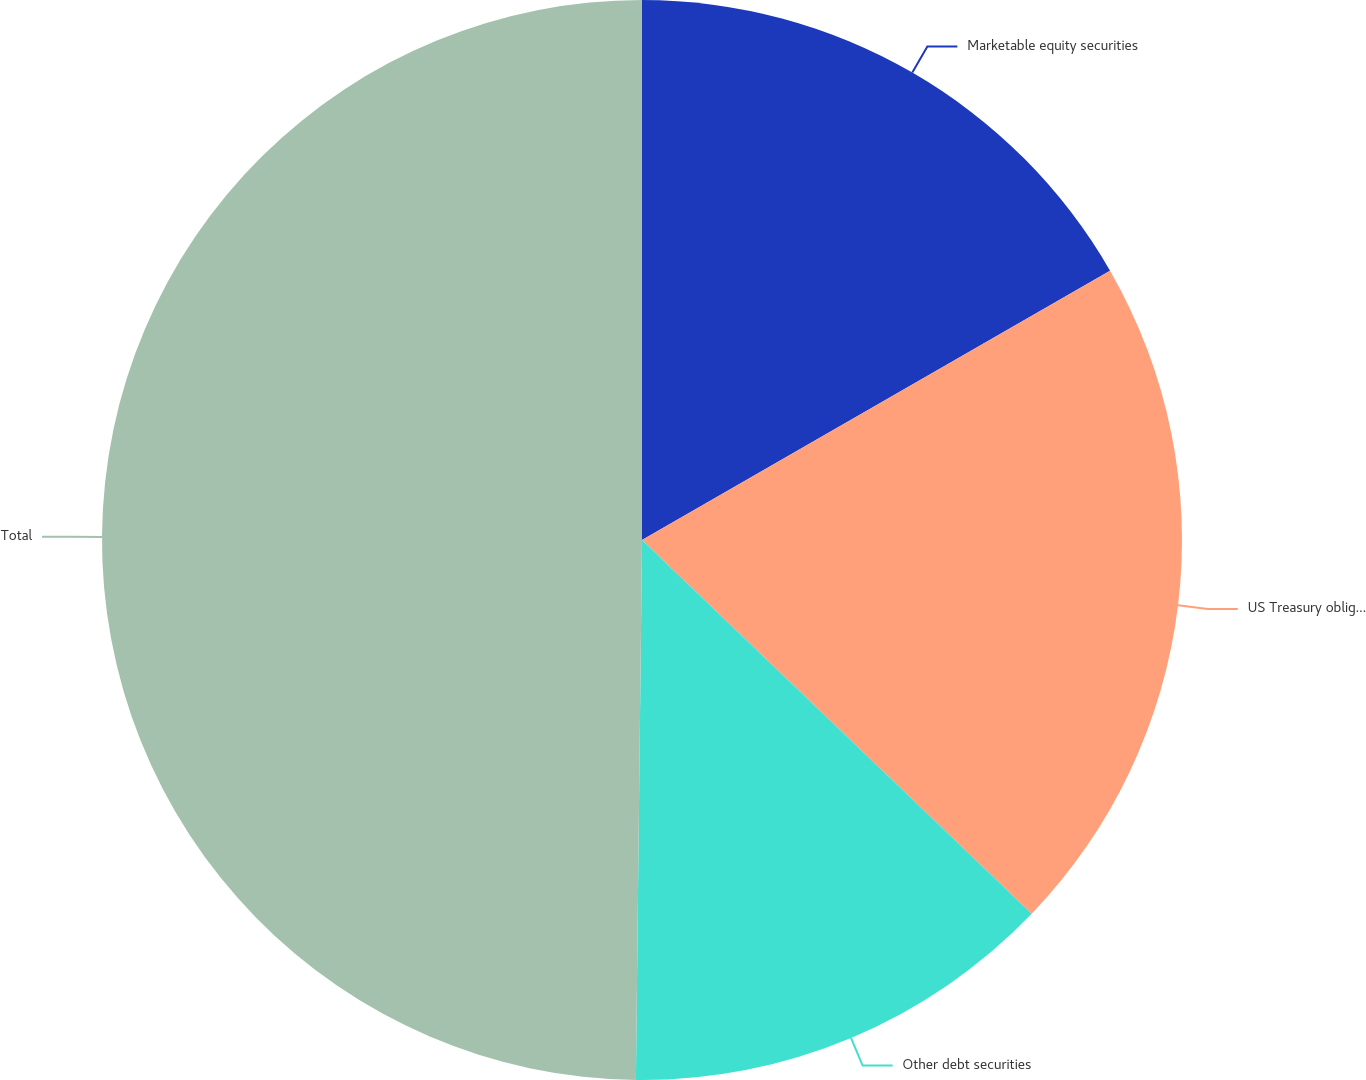Convert chart to OTSL. <chart><loc_0><loc_0><loc_500><loc_500><pie_chart><fcel>Marketable equity securities<fcel>US Treasury obligations and<fcel>Other debt securities<fcel>Total<nl><fcel>16.69%<fcel>20.48%<fcel>13.01%<fcel>49.82%<nl></chart> 